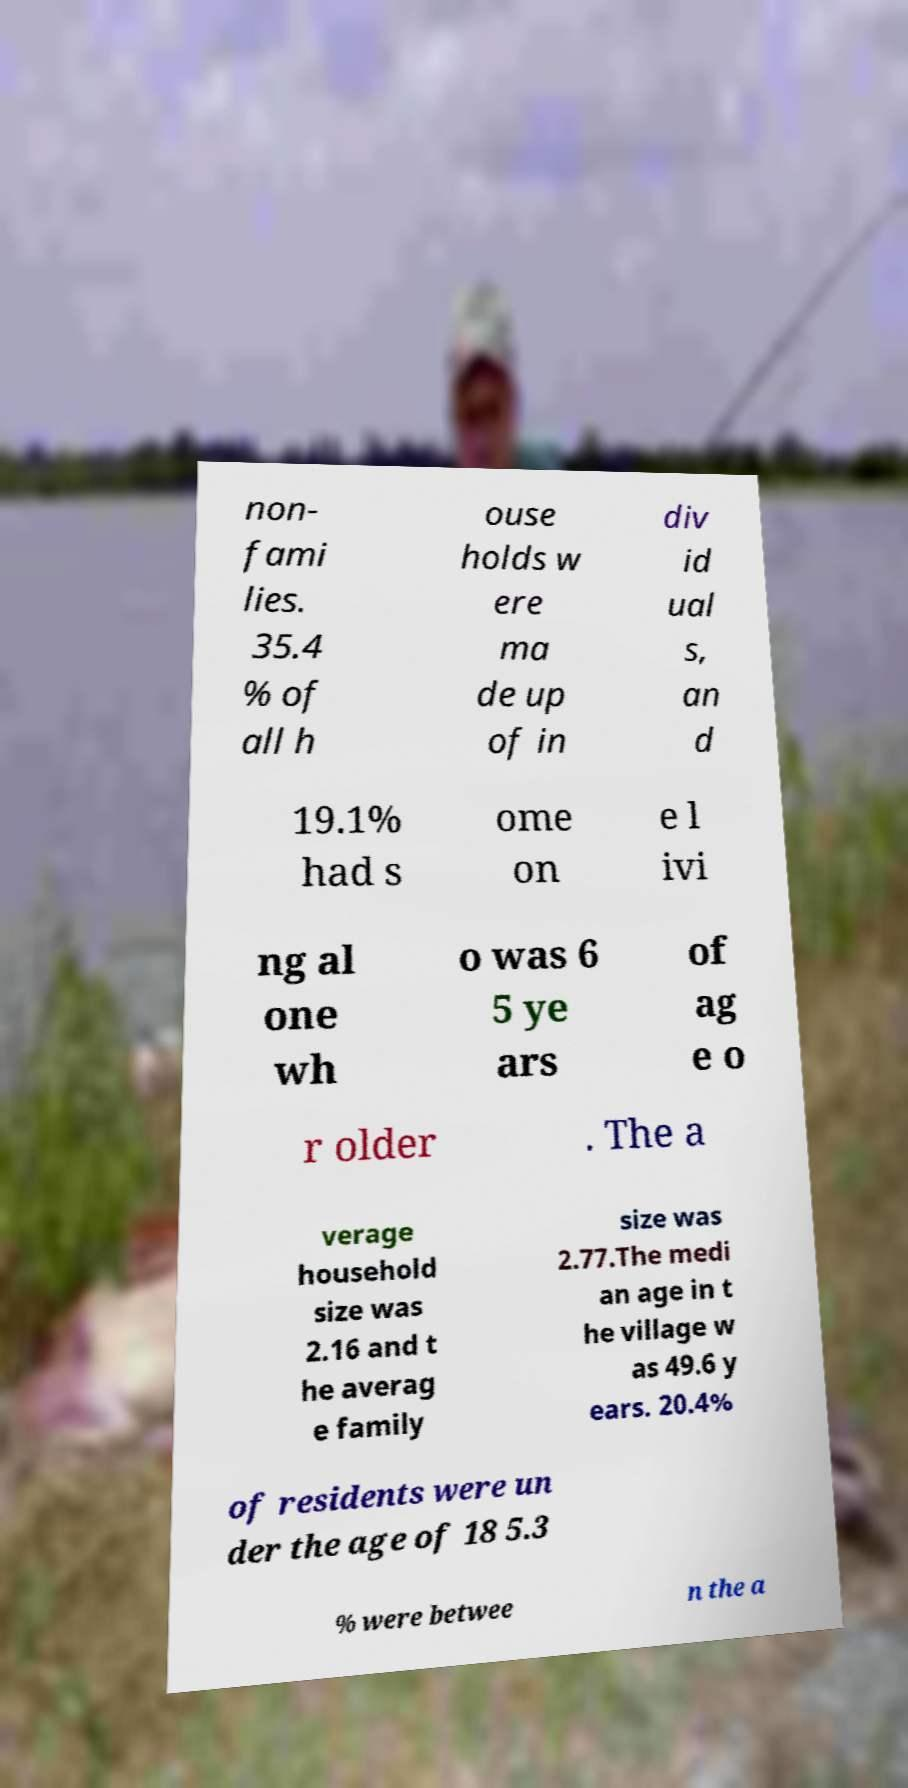There's text embedded in this image that I need extracted. Can you transcribe it verbatim? non- fami lies. 35.4 % of all h ouse holds w ere ma de up of in div id ual s, an d 19.1% had s ome on e l ivi ng al one wh o was 6 5 ye ars of ag e o r older . The a verage household size was 2.16 and t he averag e family size was 2.77.The medi an age in t he village w as 49.6 y ears. 20.4% of residents were un der the age of 18 5.3 % were betwee n the a 